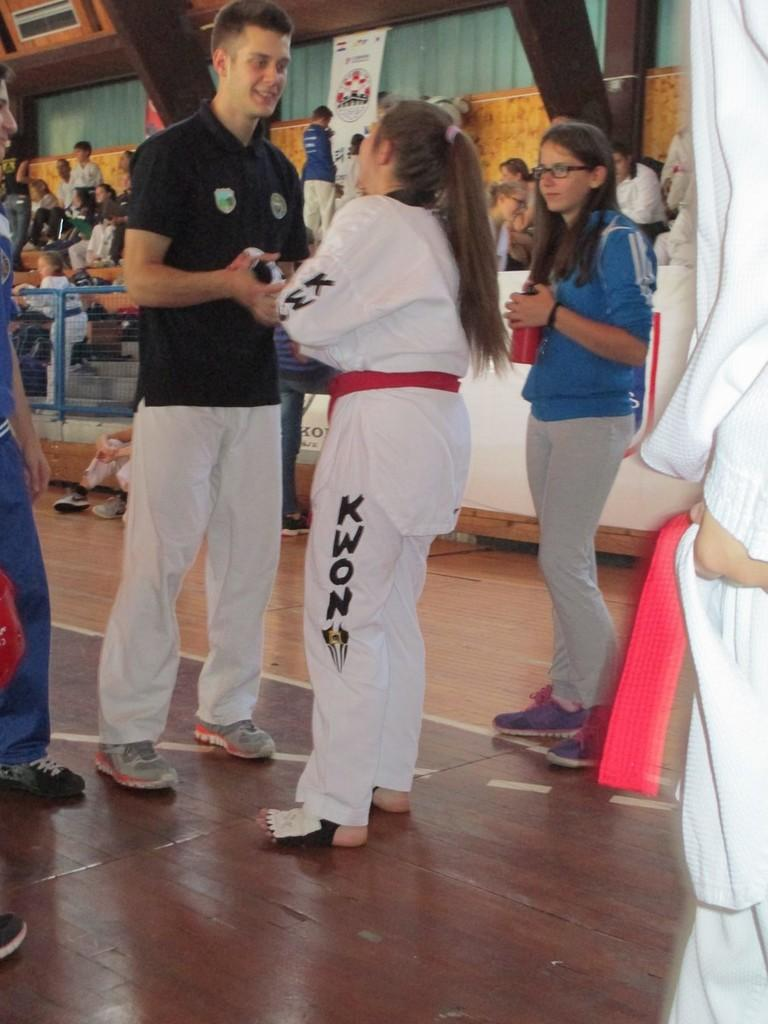<image>
Write a terse but informative summary of the picture. A woman has the word KWON on the pants of her karate uniform. 